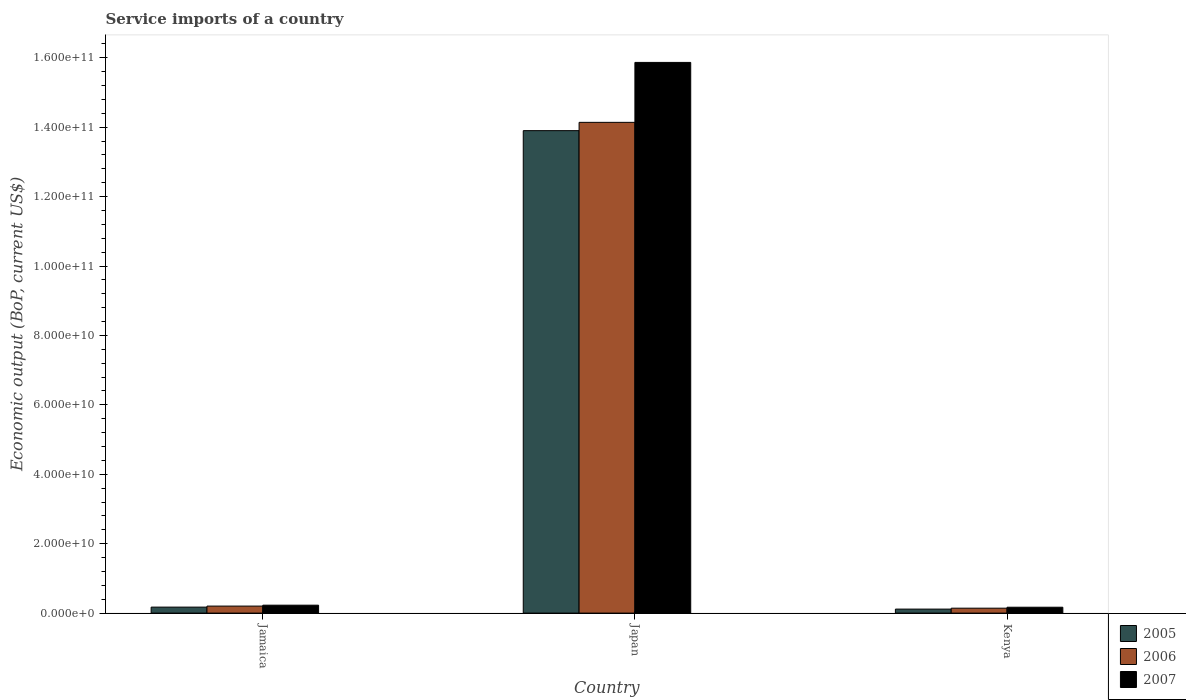How many bars are there on the 2nd tick from the left?
Ensure brevity in your answer.  3. What is the label of the 1st group of bars from the left?
Provide a short and direct response. Jamaica. What is the service imports in 2007 in Kenya?
Ensure brevity in your answer.  1.69e+09. Across all countries, what is the maximum service imports in 2006?
Your response must be concise. 1.41e+11. Across all countries, what is the minimum service imports in 2007?
Keep it short and to the point. 1.69e+09. In which country was the service imports in 2005 maximum?
Your response must be concise. Japan. In which country was the service imports in 2006 minimum?
Provide a succinct answer. Kenya. What is the total service imports in 2005 in the graph?
Provide a short and direct response. 1.42e+11. What is the difference between the service imports in 2006 in Jamaica and that in Japan?
Ensure brevity in your answer.  -1.39e+11. What is the difference between the service imports in 2007 in Kenya and the service imports in 2005 in Japan?
Provide a short and direct response. -1.37e+11. What is the average service imports in 2006 per country?
Keep it short and to the point. 4.83e+1. What is the difference between the service imports of/in 2007 and service imports of/in 2006 in Jamaica?
Your answer should be compact. 2.61e+08. In how many countries, is the service imports in 2006 greater than 72000000000 US$?
Give a very brief answer. 1. What is the ratio of the service imports in 2007 in Japan to that in Kenya?
Your answer should be compact. 93.87. Is the service imports in 2007 in Jamaica less than that in Japan?
Keep it short and to the point. Yes. What is the difference between the highest and the second highest service imports in 2005?
Ensure brevity in your answer.  1.37e+11. What is the difference between the highest and the lowest service imports in 2006?
Your answer should be compact. 1.40e+11. How many bars are there?
Provide a short and direct response. 9. How many countries are there in the graph?
Provide a short and direct response. 3. Does the graph contain grids?
Your response must be concise. No. Where does the legend appear in the graph?
Your answer should be compact. Bottom right. How many legend labels are there?
Provide a short and direct response. 3. What is the title of the graph?
Provide a succinct answer. Service imports of a country. What is the label or title of the Y-axis?
Keep it short and to the point. Economic output (BoP, current US$). What is the Economic output (BoP, current US$) of 2005 in Jamaica?
Give a very brief answer. 1.72e+09. What is the Economic output (BoP, current US$) of 2006 in Jamaica?
Provide a succinct answer. 2.02e+09. What is the Economic output (BoP, current US$) in 2007 in Jamaica?
Give a very brief answer. 2.28e+09. What is the Economic output (BoP, current US$) in 2005 in Japan?
Give a very brief answer. 1.39e+11. What is the Economic output (BoP, current US$) of 2006 in Japan?
Your answer should be very brief. 1.41e+11. What is the Economic output (BoP, current US$) in 2007 in Japan?
Provide a short and direct response. 1.59e+11. What is the Economic output (BoP, current US$) of 2005 in Kenya?
Your response must be concise. 1.15e+09. What is the Economic output (BoP, current US$) in 2006 in Kenya?
Offer a terse response. 1.42e+09. What is the Economic output (BoP, current US$) in 2007 in Kenya?
Ensure brevity in your answer.  1.69e+09. Across all countries, what is the maximum Economic output (BoP, current US$) in 2005?
Provide a short and direct response. 1.39e+11. Across all countries, what is the maximum Economic output (BoP, current US$) in 2006?
Offer a very short reply. 1.41e+11. Across all countries, what is the maximum Economic output (BoP, current US$) in 2007?
Your answer should be very brief. 1.59e+11. Across all countries, what is the minimum Economic output (BoP, current US$) in 2005?
Your answer should be compact. 1.15e+09. Across all countries, what is the minimum Economic output (BoP, current US$) of 2006?
Offer a very short reply. 1.42e+09. Across all countries, what is the minimum Economic output (BoP, current US$) in 2007?
Offer a terse response. 1.69e+09. What is the total Economic output (BoP, current US$) of 2005 in the graph?
Provide a short and direct response. 1.42e+11. What is the total Economic output (BoP, current US$) of 2006 in the graph?
Offer a very short reply. 1.45e+11. What is the total Economic output (BoP, current US$) in 2007 in the graph?
Your answer should be very brief. 1.63e+11. What is the difference between the Economic output (BoP, current US$) of 2005 in Jamaica and that in Japan?
Give a very brief answer. -1.37e+11. What is the difference between the Economic output (BoP, current US$) of 2006 in Jamaica and that in Japan?
Give a very brief answer. -1.39e+11. What is the difference between the Economic output (BoP, current US$) of 2007 in Jamaica and that in Japan?
Give a very brief answer. -1.56e+11. What is the difference between the Economic output (BoP, current US$) of 2005 in Jamaica and that in Kenya?
Offer a very short reply. 5.70e+08. What is the difference between the Economic output (BoP, current US$) of 2006 in Jamaica and that in Kenya?
Your response must be concise. 6.02e+08. What is the difference between the Economic output (BoP, current US$) of 2007 in Jamaica and that in Kenya?
Make the answer very short. 5.91e+08. What is the difference between the Economic output (BoP, current US$) in 2005 in Japan and that in Kenya?
Offer a very short reply. 1.38e+11. What is the difference between the Economic output (BoP, current US$) in 2006 in Japan and that in Kenya?
Give a very brief answer. 1.40e+11. What is the difference between the Economic output (BoP, current US$) in 2007 in Japan and that in Kenya?
Offer a very short reply. 1.57e+11. What is the difference between the Economic output (BoP, current US$) in 2005 in Jamaica and the Economic output (BoP, current US$) in 2006 in Japan?
Make the answer very short. -1.40e+11. What is the difference between the Economic output (BoP, current US$) in 2005 in Jamaica and the Economic output (BoP, current US$) in 2007 in Japan?
Your answer should be very brief. -1.57e+11. What is the difference between the Economic output (BoP, current US$) in 2006 in Jamaica and the Economic output (BoP, current US$) in 2007 in Japan?
Your answer should be very brief. -1.57e+11. What is the difference between the Economic output (BoP, current US$) of 2005 in Jamaica and the Economic output (BoP, current US$) of 2006 in Kenya?
Provide a succinct answer. 3.03e+08. What is the difference between the Economic output (BoP, current US$) of 2005 in Jamaica and the Economic output (BoP, current US$) of 2007 in Kenya?
Your response must be concise. 3.17e+07. What is the difference between the Economic output (BoP, current US$) of 2006 in Jamaica and the Economic output (BoP, current US$) of 2007 in Kenya?
Give a very brief answer. 3.31e+08. What is the difference between the Economic output (BoP, current US$) in 2005 in Japan and the Economic output (BoP, current US$) in 2006 in Kenya?
Your answer should be very brief. 1.38e+11. What is the difference between the Economic output (BoP, current US$) in 2005 in Japan and the Economic output (BoP, current US$) in 2007 in Kenya?
Your answer should be compact. 1.37e+11. What is the difference between the Economic output (BoP, current US$) in 2006 in Japan and the Economic output (BoP, current US$) in 2007 in Kenya?
Provide a short and direct response. 1.40e+11. What is the average Economic output (BoP, current US$) of 2005 per country?
Provide a succinct answer. 4.73e+1. What is the average Economic output (BoP, current US$) in 2006 per country?
Your answer should be very brief. 4.83e+1. What is the average Economic output (BoP, current US$) of 2007 per country?
Offer a terse response. 5.42e+1. What is the difference between the Economic output (BoP, current US$) in 2005 and Economic output (BoP, current US$) in 2006 in Jamaica?
Provide a short and direct response. -2.99e+08. What is the difference between the Economic output (BoP, current US$) of 2005 and Economic output (BoP, current US$) of 2007 in Jamaica?
Make the answer very short. -5.60e+08. What is the difference between the Economic output (BoP, current US$) of 2006 and Economic output (BoP, current US$) of 2007 in Jamaica?
Keep it short and to the point. -2.61e+08. What is the difference between the Economic output (BoP, current US$) of 2005 and Economic output (BoP, current US$) of 2006 in Japan?
Your answer should be very brief. -2.39e+09. What is the difference between the Economic output (BoP, current US$) in 2005 and Economic output (BoP, current US$) in 2007 in Japan?
Your answer should be compact. -1.97e+1. What is the difference between the Economic output (BoP, current US$) of 2006 and Economic output (BoP, current US$) of 2007 in Japan?
Give a very brief answer. -1.73e+1. What is the difference between the Economic output (BoP, current US$) of 2005 and Economic output (BoP, current US$) of 2006 in Kenya?
Make the answer very short. -2.67e+08. What is the difference between the Economic output (BoP, current US$) of 2005 and Economic output (BoP, current US$) of 2007 in Kenya?
Your response must be concise. -5.38e+08. What is the difference between the Economic output (BoP, current US$) in 2006 and Economic output (BoP, current US$) in 2007 in Kenya?
Offer a very short reply. -2.71e+08. What is the ratio of the Economic output (BoP, current US$) in 2005 in Jamaica to that in Japan?
Offer a very short reply. 0.01. What is the ratio of the Economic output (BoP, current US$) of 2006 in Jamaica to that in Japan?
Give a very brief answer. 0.01. What is the ratio of the Economic output (BoP, current US$) in 2007 in Jamaica to that in Japan?
Provide a succinct answer. 0.01. What is the ratio of the Economic output (BoP, current US$) of 2005 in Jamaica to that in Kenya?
Your answer should be very brief. 1.49. What is the ratio of the Economic output (BoP, current US$) in 2006 in Jamaica to that in Kenya?
Make the answer very short. 1.42. What is the ratio of the Economic output (BoP, current US$) in 2007 in Jamaica to that in Kenya?
Make the answer very short. 1.35. What is the ratio of the Economic output (BoP, current US$) of 2005 in Japan to that in Kenya?
Offer a very short reply. 120.64. What is the ratio of the Economic output (BoP, current US$) of 2006 in Japan to that in Kenya?
Provide a short and direct response. 99.66. What is the ratio of the Economic output (BoP, current US$) in 2007 in Japan to that in Kenya?
Provide a short and direct response. 93.87. What is the difference between the highest and the second highest Economic output (BoP, current US$) of 2005?
Your response must be concise. 1.37e+11. What is the difference between the highest and the second highest Economic output (BoP, current US$) of 2006?
Ensure brevity in your answer.  1.39e+11. What is the difference between the highest and the second highest Economic output (BoP, current US$) of 2007?
Provide a succinct answer. 1.56e+11. What is the difference between the highest and the lowest Economic output (BoP, current US$) in 2005?
Ensure brevity in your answer.  1.38e+11. What is the difference between the highest and the lowest Economic output (BoP, current US$) of 2006?
Offer a terse response. 1.40e+11. What is the difference between the highest and the lowest Economic output (BoP, current US$) in 2007?
Your response must be concise. 1.57e+11. 